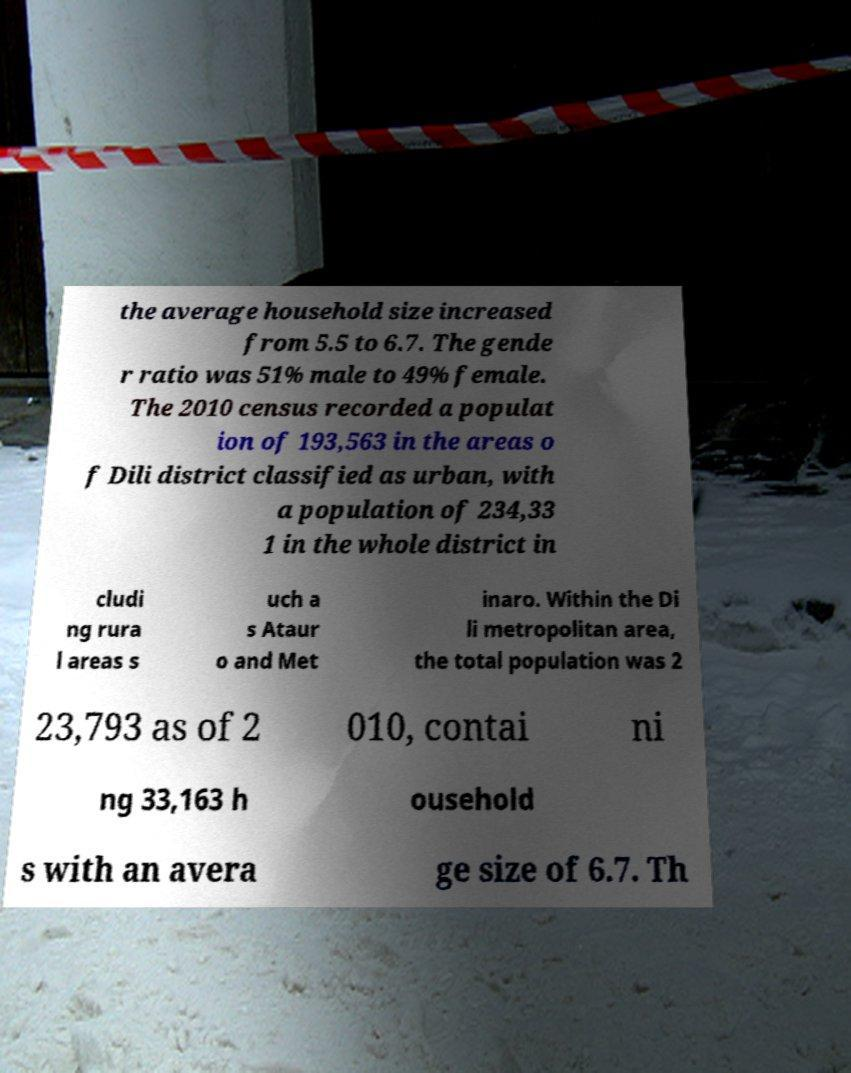For documentation purposes, I need the text within this image transcribed. Could you provide that? the average household size increased from 5.5 to 6.7. The gende r ratio was 51% male to 49% female. The 2010 census recorded a populat ion of 193,563 in the areas o f Dili district classified as urban, with a population of 234,33 1 in the whole district in cludi ng rura l areas s uch a s Ataur o and Met inaro. Within the Di li metropolitan area, the total population was 2 23,793 as of 2 010, contai ni ng 33,163 h ousehold s with an avera ge size of 6.7. Th 